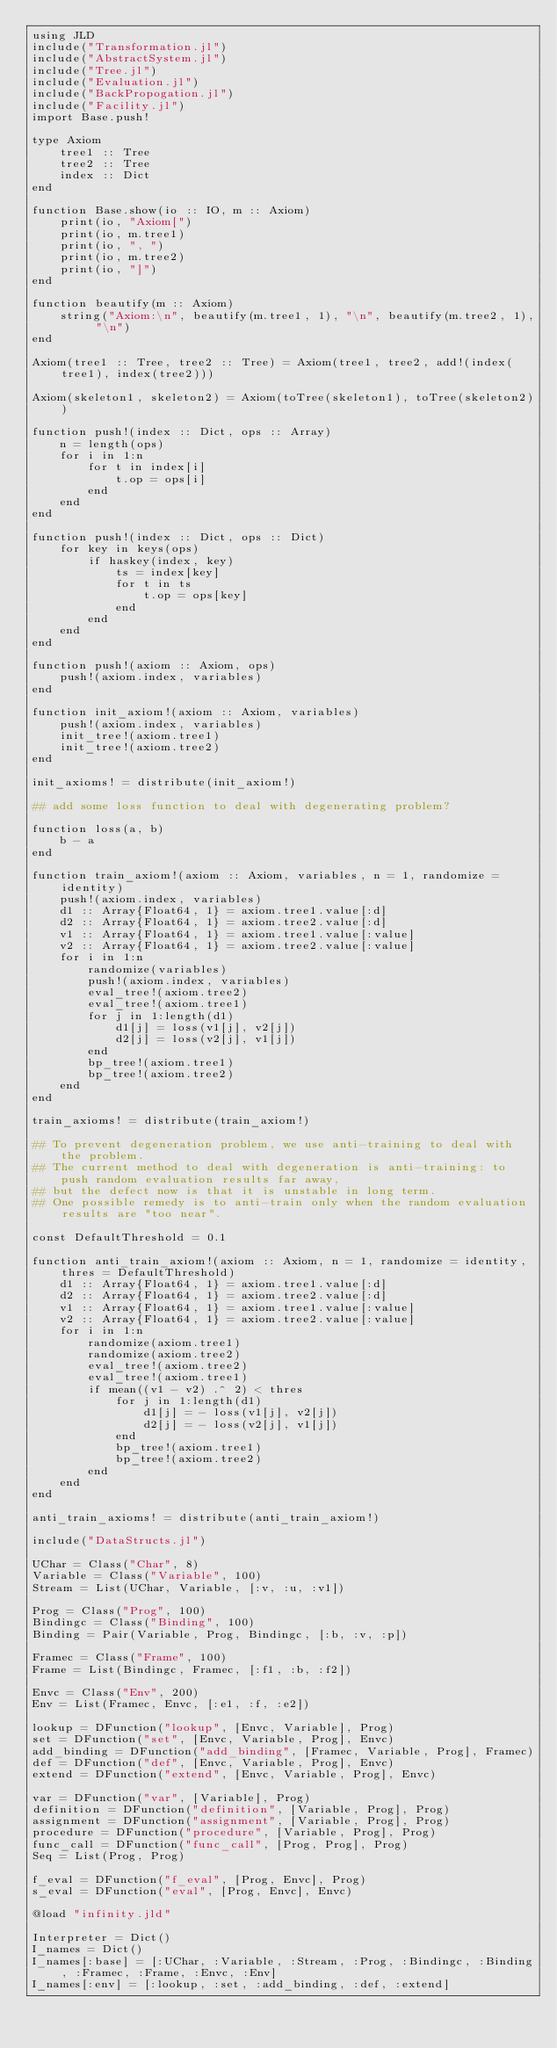<code> <loc_0><loc_0><loc_500><loc_500><_Julia_>using JLD
include("Transformation.jl")
include("AbstractSystem.jl")
include("Tree.jl")
include("Evaluation.jl")
include("BackPropogation.jl")
include("Facility.jl")
import Base.push!

type Axiom
    tree1 :: Tree
    tree2 :: Tree
    index :: Dict
end

function Base.show(io :: IO, m :: Axiom)
    print(io, "Axiom[")
    print(io, m.tree1)
    print(io, ", ")
    print(io, m.tree2)
    print(io, "]")
end

function beautify(m :: Axiom)
    string("Axiom:\n", beautify(m.tree1, 1), "\n", beautify(m.tree2, 1), "\n")
end

Axiom(tree1 :: Tree, tree2 :: Tree) = Axiom(tree1, tree2, add!(index(tree1), index(tree2)))

Axiom(skeleton1, skeleton2) = Axiom(toTree(skeleton1), toTree(skeleton2))

function push!(index :: Dict, ops :: Array)
    n = length(ops)
    for i in 1:n
        for t in index[i]
            t.op = ops[i]
        end
    end
end

function push!(index :: Dict, ops :: Dict)
    for key in keys(ops)
        if haskey(index, key)
            ts = index[key]
            for t in ts
                t.op = ops[key]
            end
        end
    end
end

function push!(axiom :: Axiom, ops)
    push!(axiom.index, variables)
end

function init_axiom!(axiom :: Axiom, variables)
    push!(axiom.index, variables)
    init_tree!(axiom.tree1)
    init_tree!(axiom.tree2)
end

init_axioms! = distribute(init_axiom!)

## add some loss function to deal with degenerating problem?

function loss(a, b)
    b - a
end

function train_axiom!(axiom :: Axiom, variables, n = 1, randomize = identity)
    push!(axiom.index, variables)
    d1 :: Array{Float64, 1} = axiom.tree1.value[:d]
    d2 :: Array{Float64, 1} = axiom.tree2.value[:d]
    v1 :: Array{Float64, 1} = axiom.tree1.value[:value]
    v2 :: Array{Float64, 1} = axiom.tree2.value[:value]
    for i in 1:n
        randomize(variables)
        push!(axiom.index, variables)
        eval_tree!(axiom.tree2)
        eval_tree!(axiom.tree1)
        for j in 1:length(d1)
            d1[j] = loss(v1[j], v2[j])
            d2[j] = loss(v2[j], v1[j])
        end
        bp_tree!(axiom.tree1)
        bp_tree!(axiom.tree2)
    end
end

train_axioms! = distribute(train_axiom!)

## To prevent degeneration problem, we use anti-training to deal with the problem.
## The current method to deal with degeneration is anti-training: to push random evaluation results far away,
## but the defect now is that it is unstable in long term.
## One possible remedy is to anti-train only when the random evaluation results are "too near".

const DefaultThreshold = 0.1

function anti_train_axiom!(axiom :: Axiom, n = 1, randomize = identity, thres = DefaultThreshold)
    d1 :: Array{Float64, 1} = axiom.tree1.value[:d]
    d2 :: Array{Float64, 1} = axiom.tree2.value[:d]
    v1 :: Array{Float64, 1} = axiom.tree1.value[:value]
    v2 :: Array{Float64, 1} = axiom.tree2.value[:value]
    for i in 1:n
        randomize(axiom.tree1)
        randomize(axiom.tree2)
        eval_tree!(axiom.tree2)
        eval_tree!(axiom.tree1)
        if mean((v1 - v2) .^ 2) < thres
            for j in 1:length(d1)
                d1[j] = - loss(v1[j], v2[j])
                d2[j] = - loss(v2[j], v1[j])
            end
            bp_tree!(axiom.tree1)
            bp_tree!(axiom.tree2)
        end
    end
end

anti_train_axioms! = distribute(anti_train_axiom!)

include("DataStructs.jl")

UChar = Class("Char", 8)
Variable = Class("Variable", 100)
Stream = List(UChar, Variable, [:v, :u, :v1])

Prog = Class("Prog", 100)
Bindingc = Class("Binding", 100)
Binding = Pair(Variable, Prog, Bindingc, [:b, :v, :p])

Framec = Class("Frame", 100)
Frame = List(Bindingc, Framec, [:f1, :b, :f2])

Envc = Class("Env", 200)
Env = List(Framec, Envc, [:e1, :f, :e2])

lookup = DFunction("lookup", [Envc, Variable], Prog)
set = DFunction("set", [Envc, Variable, Prog], Envc)
add_binding = DFunction("add_binding", [Framec, Variable, Prog], Framec)
def = DFunction("def", [Envc, Variable, Prog], Envc)
extend = DFunction("extend", [Envc, Variable, Prog], Envc)

var = DFunction("var", [Variable], Prog)
definition = DFunction("definition", [Variable, Prog], Prog) 
assignment = DFunction("assignment", [Variable, Prog], Prog) 
procedure = DFunction("procedure", [Variable, Prog], Prog)
func_call = DFunction("func_call", [Prog, Prog], Prog)
Seq = List(Prog, Prog)

f_eval = DFunction("f_eval", [Prog, Envc], Prog)
s_eval = DFunction("eval", [Prog, Envc], Envc)

@load "infinity.jld"

Interpreter = Dict()
I_names = Dict()
I_names[:base] = [:UChar, :Variable, :Stream, :Prog, :Bindingc, :Binding, :Framec, :Frame, :Envc, :Env]
I_names[:env] = [:lookup, :set, :add_binding, :def, :extend]</code> 